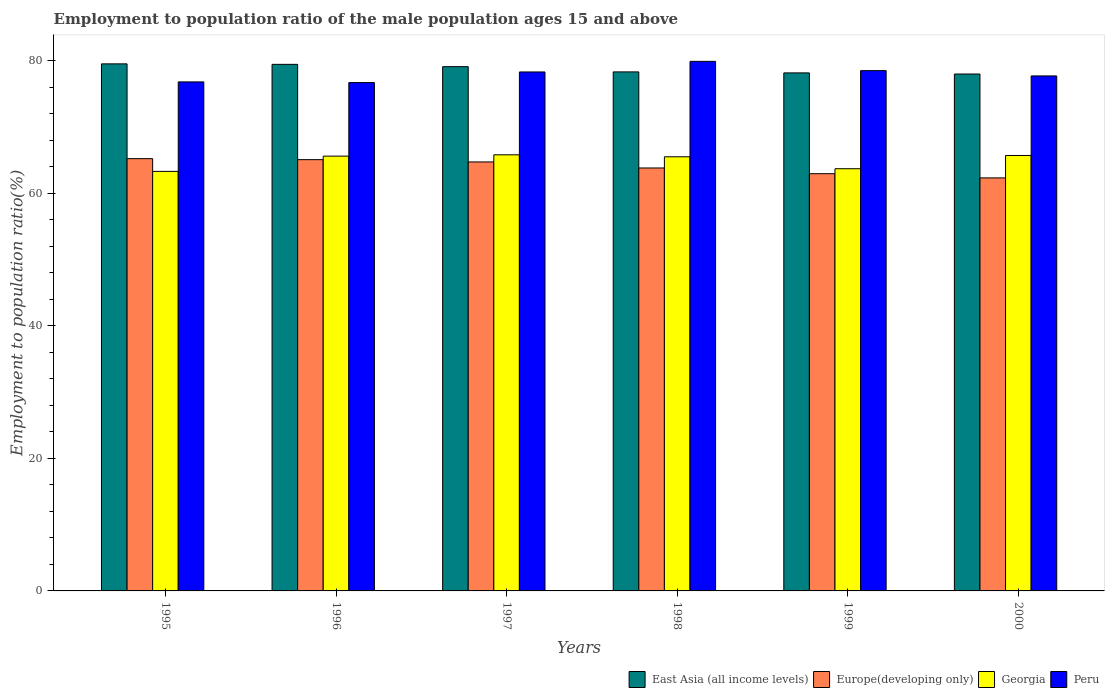How many groups of bars are there?
Ensure brevity in your answer.  6. Are the number of bars on each tick of the X-axis equal?
Keep it short and to the point. Yes. How many bars are there on the 1st tick from the left?
Your response must be concise. 4. How many bars are there on the 2nd tick from the right?
Provide a short and direct response. 4. What is the employment to population ratio in Europe(developing only) in 2000?
Offer a terse response. 62.32. Across all years, what is the maximum employment to population ratio in Peru?
Provide a succinct answer. 79.9. Across all years, what is the minimum employment to population ratio in East Asia (all income levels)?
Offer a very short reply. 77.99. In which year was the employment to population ratio in Peru maximum?
Make the answer very short. 1998. In which year was the employment to population ratio in Peru minimum?
Provide a succinct answer. 1996. What is the total employment to population ratio in Europe(developing only) in the graph?
Your answer should be very brief. 384.09. What is the difference between the employment to population ratio in Peru in 1997 and that in 1998?
Your answer should be very brief. -1.6. What is the difference between the employment to population ratio in East Asia (all income levels) in 2000 and the employment to population ratio in Europe(developing only) in 1995?
Keep it short and to the point. 12.77. What is the average employment to population ratio in Europe(developing only) per year?
Ensure brevity in your answer.  64.02. In the year 1998, what is the difference between the employment to population ratio in Peru and employment to population ratio in Georgia?
Offer a very short reply. 14.4. In how many years, is the employment to population ratio in Peru greater than 28 %?
Provide a succinct answer. 6. What is the ratio of the employment to population ratio in Georgia in 1998 to that in 2000?
Offer a terse response. 1. Is the employment to population ratio in Peru in 1996 less than that in 1998?
Your answer should be very brief. Yes. Is the difference between the employment to population ratio in Peru in 1995 and 1996 greater than the difference between the employment to population ratio in Georgia in 1995 and 1996?
Keep it short and to the point. Yes. What is the difference between the highest and the second highest employment to population ratio in Georgia?
Offer a terse response. 0.1. What is the difference between the highest and the lowest employment to population ratio in Peru?
Your response must be concise. 3.2. In how many years, is the employment to population ratio in Georgia greater than the average employment to population ratio in Georgia taken over all years?
Ensure brevity in your answer.  4. Is it the case that in every year, the sum of the employment to population ratio in Peru and employment to population ratio in Georgia is greater than the sum of employment to population ratio in Europe(developing only) and employment to population ratio in East Asia (all income levels)?
Your response must be concise. Yes. What does the 1st bar from the left in 1997 represents?
Ensure brevity in your answer.  East Asia (all income levels). What does the 4th bar from the right in 2000 represents?
Offer a terse response. East Asia (all income levels). Is it the case that in every year, the sum of the employment to population ratio in Georgia and employment to population ratio in East Asia (all income levels) is greater than the employment to population ratio in Peru?
Your answer should be compact. Yes. How many bars are there?
Your answer should be very brief. 24. Are all the bars in the graph horizontal?
Provide a short and direct response. No. What is the difference between two consecutive major ticks on the Y-axis?
Your response must be concise. 20. Does the graph contain any zero values?
Offer a terse response. No. Does the graph contain grids?
Your answer should be very brief. No. How many legend labels are there?
Ensure brevity in your answer.  4. How are the legend labels stacked?
Keep it short and to the point. Horizontal. What is the title of the graph?
Offer a terse response. Employment to population ratio of the male population ages 15 and above. Does "Luxembourg" appear as one of the legend labels in the graph?
Give a very brief answer. No. What is the label or title of the X-axis?
Give a very brief answer. Years. What is the Employment to population ratio(%) in East Asia (all income levels) in 1995?
Offer a very short reply. 79.52. What is the Employment to population ratio(%) in Europe(developing only) in 1995?
Provide a short and direct response. 65.22. What is the Employment to population ratio(%) of Georgia in 1995?
Make the answer very short. 63.3. What is the Employment to population ratio(%) in Peru in 1995?
Keep it short and to the point. 76.8. What is the Employment to population ratio(%) in East Asia (all income levels) in 1996?
Keep it short and to the point. 79.45. What is the Employment to population ratio(%) in Europe(developing only) in 1996?
Your answer should be compact. 65.07. What is the Employment to population ratio(%) of Georgia in 1996?
Offer a very short reply. 65.6. What is the Employment to population ratio(%) of Peru in 1996?
Offer a terse response. 76.7. What is the Employment to population ratio(%) of East Asia (all income levels) in 1997?
Offer a terse response. 79.1. What is the Employment to population ratio(%) in Europe(developing only) in 1997?
Give a very brief answer. 64.72. What is the Employment to population ratio(%) in Georgia in 1997?
Keep it short and to the point. 65.8. What is the Employment to population ratio(%) of Peru in 1997?
Provide a short and direct response. 78.3. What is the Employment to population ratio(%) of East Asia (all income levels) in 1998?
Give a very brief answer. 78.31. What is the Employment to population ratio(%) in Europe(developing only) in 1998?
Your answer should be compact. 63.81. What is the Employment to population ratio(%) in Georgia in 1998?
Offer a very short reply. 65.5. What is the Employment to population ratio(%) in Peru in 1998?
Make the answer very short. 79.9. What is the Employment to population ratio(%) in East Asia (all income levels) in 1999?
Make the answer very short. 78.16. What is the Employment to population ratio(%) of Europe(developing only) in 1999?
Ensure brevity in your answer.  62.95. What is the Employment to population ratio(%) in Georgia in 1999?
Make the answer very short. 63.7. What is the Employment to population ratio(%) in Peru in 1999?
Provide a short and direct response. 78.5. What is the Employment to population ratio(%) in East Asia (all income levels) in 2000?
Your response must be concise. 77.99. What is the Employment to population ratio(%) in Europe(developing only) in 2000?
Give a very brief answer. 62.32. What is the Employment to population ratio(%) in Georgia in 2000?
Offer a very short reply. 65.7. What is the Employment to population ratio(%) in Peru in 2000?
Offer a very short reply. 77.7. Across all years, what is the maximum Employment to population ratio(%) in East Asia (all income levels)?
Your answer should be compact. 79.52. Across all years, what is the maximum Employment to population ratio(%) of Europe(developing only)?
Offer a terse response. 65.22. Across all years, what is the maximum Employment to population ratio(%) in Georgia?
Make the answer very short. 65.8. Across all years, what is the maximum Employment to population ratio(%) of Peru?
Your response must be concise. 79.9. Across all years, what is the minimum Employment to population ratio(%) of East Asia (all income levels)?
Give a very brief answer. 77.99. Across all years, what is the minimum Employment to population ratio(%) of Europe(developing only)?
Offer a very short reply. 62.32. Across all years, what is the minimum Employment to population ratio(%) in Georgia?
Offer a very short reply. 63.3. Across all years, what is the minimum Employment to population ratio(%) of Peru?
Offer a terse response. 76.7. What is the total Employment to population ratio(%) in East Asia (all income levels) in the graph?
Provide a short and direct response. 472.53. What is the total Employment to population ratio(%) of Europe(developing only) in the graph?
Your answer should be compact. 384.09. What is the total Employment to population ratio(%) in Georgia in the graph?
Make the answer very short. 389.6. What is the total Employment to population ratio(%) of Peru in the graph?
Offer a very short reply. 467.9. What is the difference between the Employment to population ratio(%) in East Asia (all income levels) in 1995 and that in 1996?
Provide a short and direct response. 0.07. What is the difference between the Employment to population ratio(%) in Europe(developing only) in 1995 and that in 1996?
Your answer should be compact. 0.15. What is the difference between the Employment to population ratio(%) of Peru in 1995 and that in 1996?
Give a very brief answer. 0.1. What is the difference between the Employment to population ratio(%) of East Asia (all income levels) in 1995 and that in 1997?
Ensure brevity in your answer.  0.42. What is the difference between the Employment to population ratio(%) in Europe(developing only) in 1995 and that in 1997?
Your answer should be very brief. 0.5. What is the difference between the Employment to population ratio(%) in Georgia in 1995 and that in 1997?
Your answer should be very brief. -2.5. What is the difference between the Employment to population ratio(%) of East Asia (all income levels) in 1995 and that in 1998?
Your answer should be compact. 1.21. What is the difference between the Employment to population ratio(%) in Europe(developing only) in 1995 and that in 1998?
Your response must be concise. 1.41. What is the difference between the Employment to population ratio(%) of Georgia in 1995 and that in 1998?
Your answer should be compact. -2.2. What is the difference between the Employment to population ratio(%) of Peru in 1995 and that in 1998?
Your response must be concise. -3.1. What is the difference between the Employment to population ratio(%) in East Asia (all income levels) in 1995 and that in 1999?
Provide a short and direct response. 1.36. What is the difference between the Employment to population ratio(%) in Europe(developing only) in 1995 and that in 1999?
Give a very brief answer. 2.27. What is the difference between the Employment to population ratio(%) of Georgia in 1995 and that in 1999?
Make the answer very short. -0.4. What is the difference between the Employment to population ratio(%) of Peru in 1995 and that in 1999?
Your answer should be very brief. -1.7. What is the difference between the Employment to population ratio(%) in East Asia (all income levels) in 1995 and that in 2000?
Your answer should be very brief. 1.53. What is the difference between the Employment to population ratio(%) of Europe(developing only) in 1995 and that in 2000?
Provide a succinct answer. 2.9. What is the difference between the Employment to population ratio(%) in Peru in 1995 and that in 2000?
Keep it short and to the point. -0.9. What is the difference between the Employment to population ratio(%) of East Asia (all income levels) in 1996 and that in 1997?
Keep it short and to the point. 0.35. What is the difference between the Employment to population ratio(%) of Europe(developing only) in 1996 and that in 1997?
Your response must be concise. 0.35. What is the difference between the Employment to population ratio(%) in Peru in 1996 and that in 1997?
Provide a succinct answer. -1.6. What is the difference between the Employment to population ratio(%) of East Asia (all income levels) in 1996 and that in 1998?
Make the answer very short. 1.14. What is the difference between the Employment to population ratio(%) in Europe(developing only) in 1996 and that in 1998?
Your answer should be very brief. 1.26. What is the difference between the Employment to population ratio(%) of Peru in 1996 and that in 1998?
Provide a succinct answer. -3.2. What is the difference between the Employment to population ratio(%) in East Asia (all income levels) in 1996 and that in 1999?
Offer a very short reply. 1.29. What is the difference between the Employment to population ratio(%) in Europe(developing only) in 1996 and that in 1999?
Provide a succinct answer. 2.12. What is the difference between the Employment to population ratio(%) in Georgia in 1996 and that in 1999?
Your answer should be very brief. 1.9. What is the difference between the Employment to population ratio(%) in East Asia (all income levels) in 1996 and that in 2000?
Make the answer very short. 1.46. What is the difference between the Employment to population ratio(%) of Europe(developing only) in 1996 and that in 2000?
Offer a terse response. 2.75. What is the difference between the Employment to population ratio(%) in Georgia in 1996 and that in 2000?
Your answer should be very brief. -0.1. What is the difference between the Employment to population ratio(%) of Peru in 1996 and that in 2000?
Keep it short and to the point. -1. What is the difference between the Employment to population ratio(%) in East Asia (all income levels) in 1997 and that in 1998?
Provide a short and direct response. 0.79. What is the difference between the Employment to population ratio(%) of Europe(developing only) in 1997 and that in 1998?
Your response must be concise. 0.91. What is the difference between the Employment to population ratio(%) in Georgia in 1997 and that in 1998?
Offer a terse response. 0.3. What is the difference between the Employment to population ratio(%) in East Asia (all income levels) in 1997 and that in 1999?
Your response must be concise. 0.94. What is the difference between the Employment to population ratio(%) of Europe(developing only) in 1997 and that in 1999?
Offer a very short reply. 1.77. What is the difference between the Employment to population ratio(%) of Georgia in 1997 and that in 1999?
Give a very brief answer. 2.1. What is the difference between the Employment to population ratio(%) of East Asia (all income levels) in 1997 and that in 2000?
Make the answer very short. 1.11. What is the difference between the Employment to population ratio(%) of Europe(developing only) in 1997 and that in 2000?
Your answer should be compact. 2.41. What is the difference between the Employment to population ratio(%) of East Asia (all income levels) in 1998 and that in 1999?
Your answer should be compact. 0.15. What is the difference between the Employment to population ratio(%) in Europe(developing only) in 1998 and that in 1999?
Keep it short and to the point. 0.86. What is the difference between the Employment to population ratio(%) of Georgia in 1998 and that in 1999?
Provide a succinct answer. 1.8. What is the difference between the Employment to population ratio(%) in East Asia (all income levels) in 1998 and that in 2000?
Ensure brevity in your answer.  0.32. What is the difference between the Employment to population ratio(%) of Europe(developing only) in 1998 and that in 2000?
Offer a very short reply. 1.5. What is the difference between the Employment to population ratio(%) of Georgia in 1998 and that in 2000?
Provide a short and direct response. -0.2. What is the difference between the Employment to population ratio(%) in East Asia (all income levels) in 1999 and that in 2000?
Ensure brevity in your answer.  0.17. What is the difference between the Employment to population ratio(%) of Europe(developing only) in 1999 and that in 2000?
Your answer should be compact. 0.63. What is the difference between the Employment to population ratio(%) in Peru in 1999 and that in 2000?
Provide a short and direct response. 0.8. What is the difference between the Employment to population ratio(%) in East Asia (all income levels) in 1995 and the Employment to population ratio(%) in Europe(developing only) in 1996?
Your answer should be very brief. 14.45. What is the difference between the Employment to population ratio(%) of East Asia (all income levels) in 1995 and the Employment to population ratio(%) of Georgia in 1996?
Offer a terse response. 13.92. What is the difference between the Employment to population ratio(%) in East Asia (all income levels) in 1995 and the Employment to population ratio(%) in Peru in 1996?
Offer a very short reply. 2.82. What is the difference between the Employment to population ratio(%) in Europe(developing only) in 1995 and the Employment to population ratio(%) in Georgia in 1996?
Your answer should be compact. -0.38. What is the difference between the Employment to population ratio(%) in Europe(developing only) in 1995 and the Employment to population ratio(%) in Peru in 1996?
Provide a succinct answer. -11.48. What is the difference between the Employment to population ratio(%) in Georgia in 1995 and the Employment to population ratio(%) in Peru in 1996?
Your response must be concise. -13.4. What is the difference between the Employment to population ratio(%) of East Asia (all income levels) in 1995 and the Employment to population ratio(%) of Europe(developing only) in 1997?
Keep it short and to the point. 14.8. What is the difference between the Employment to population ratio(%) in East Asia (all income levels) in 1995 and the Employment to population ratio(%) in Georgia in 1997?
Offer a terse response. 13.72. What is the difference between the Employment to population ratio(%) of East Asia (all income levels) in 1995 and the Employment to population ratio(%) of Peru in 1997?
Provide a short and direct response. 1.22. What is the difference between the Employment to population ratio(%) in Europe(developing only) in 1995 and the Employment to population ratio(%) in Georgia in 1997?
Make the answer very short. -0.58. What is the difference between the Employment to population ratio(%) in Europe(developing only) in 1995 and the Employment to population ratio(%) in Peru in 1997?
Offer a terse response. -13.08. What is the difference between the Employment to population ratio(%) in Georgia in 1995 and the Employment to population ratio(%) in Peru in 1997?
Make the answer very short. -15. What is the difference between the Employment to population ratio(%) in East Asia (all income levels) in 1995 and the Employment to population ratio(%) in Europe(developing only) in 1998?
Your answer should be compact. 15.71. What is the difference between the Employment to population ratio(%) in East Asia (all income levels) in 1995 and the Employment to population ratio(%) in Georgia in 1998?
Provide a short and direct response. 14.02. What is the difference between the Employment to population ratio(%) of East Asia (all income levels) in 1995 and the Employment to population ratio(%) of Peru in 1998?
Provide a succinct answer. -0.38. What is the difference between the Employment to population ratio(%) in Europe(developing only) in 1995 and the Employment to population ratio(%) in Georgia in 1998?
Offer a terse response. -0.28. What is the difference between the Employment to population ratio(%) in Europe(developing only) in 1995 and the Employment to population ratio(%) in Peru in 1998?
Give a very brief answer. -14.68. What is the difference between the Employment to population ratio(%) in Georgia in 1995 and the Employment to population ratio(%) in Peru in 1998?
Offer a very short reply. -16.6. What is the difference between the Employment to population ratio(%) in East Asia (all income levels) in 1995 and the Employment to population ratio(%) in Europe(developing only) in 1999?
Keep it short and to the point. 16.57. What is the difference between the Employment to population ratio(%) of East Asia (all income levels) in 1995 and the Employment to population ratio(%) of Georgia in 1999?
Your answer should be compact. 15.82. What is the difference between the Employment to population ratio(%) in East Asia (all income levels) in 1995 and the Employment to population ratio(%) in Peru in 1999?
Offer a very short reply. 1.02. What is the difference between the Employment to population ratio(%) of Europe(developing only) in 1995 and the Employment to population ratio(%) of Georgia in 1999?
Ensure brevity in your answer.  1.52. What is the difference between the Employment to population ratio(%) in Europe(developing only) in 1995 and the Employment to population ratio(%) in Peru in 1999?
Your response must be concise. -13.28. What is the difference between the Employment to population ratio(%) in Georgia in 1995 and the Employment to population ratio(%) in Peru in 1999?
Your response must be concise. -15.2. What is the difference between the Employment to population ratio(%) in East Asia (all income levels) in 1995 and the Employment to population ratio(%) in Europe(developing only) in 2000?
Keep it short and to the point. 17.2. What is the difference between the Employment to population ratio(%) in East Asia (all income levels) in 1995 and the Employment to population ratio(%) in Georgia in 2000?
Your answer should be compact. 13.82. What is the difference between the Employment to population ratio(%) of East Asia (all income levels) in 1995 and the Employment to population ratio(%) of Peru in 2000?
Provide a short and direct response. 1.82. What is the difference between the Employment to population ratio(%) of Europe(developing only) in 1995 and the Employment to population ratio(%) of Georgia in 2000?
Keep it short and to the point. -0.48. What is the difference between the Employment to population ratio(%) in Europe(developing only) in 1995 and the Employment to population ratio(%) in Peru in 2000?
Your answer should be very brief. -12.48. What is the difference between the Employment to population ratio(%) of Georgia in 1995 and the Employment to population ratio(%) of Peru in 2000?
Offer a very short reply. -14.4. What is the difference between the Employment to population ratio(%) of East Asia (all income levels) in 1996 and the Employment to population ratio(%) of Europe(developing only) in 1997?
Give a very brief answer. 14.73. What is the difference between the Employment to population ratio(%) of East Asia (all income levels) in 1996 and the Employment to population ratio(%) of Georgia in 1997?
Provide a short and direct response. 13.65. What is the difference between the Employment to population ratio(%) of East Asia (all income levels) in 1996 and the Employment to population ratio(%) of Peru in 1997?
Make the answer very short. 1.15. What is the difference between the Employment to population ratio(%) of Europe(developing only) in 1996 and the Employment to population ratio(%) of Georgia in 1997?
Ensure brevity in your answer.  -0.73. What is the difference between the Employment to population ratio(%) in Europe(developing only) in 1996 and the Employment to population ratio(%) in Peru in 1997?
Give a very brief answer. -13.23. What is the difference between the Employment to population ratio(%) of Georgia in 1996 and the Employment to population ratio(%) of Peru in 1997?
Ensure brevity in your answer.  -12.7. What is the difference between the Employment to population ratio(%) in East Asia (all income levels) in 1996 and the Employment to population ratio(%) in Europe(developing only) in 1998?
Offer a terse response. 15.63. What is the difference between the Employment to population ratio(%) of East Asia (all income levels) in 1996 and the Employment to population ratio(%) of Georgia in 1998?
Your response must be concise. 13.95. What is the difference between the Employment to population ratio(%) in East Asia (all income levels) in 1996 and the Employment to population ratio(%) in Peru in 1998?
Offer a very short reply. -0.45. What is the difference between the Employment to population ratio(%) of Europe(developing only) in 1996 and the Employment to population ratio(%) of Georgia in 1998?
Your answer should be very brief. -0.43. What is the difference between the Employment to population ratio(%) in Europe(developing only) in 1996 and the Employment to population ratio(%) in Peru in 1998?
Ensure brevity in your answer.  -14.83. What is the difference between the Employment to population ratio(%) of Georgia in 1996 and the Employment to population ratio(%) of Peru in 1998?
Ensure brevity in your answer.  -14.3. What is the difference between the Employment to population ratio(%) of East Asia (all income levels) in 1996 and the Employment to population ratio(%) of Europe(developing only) in 1999?
Provide a succinct answer. 16.5. What is the difference between the Employment to population ratio(%) in East Asia (all income levels) in 1996 and the Employment to population ratio(%) in Georgia in 1999?
Ensure brevity in your answer.  15.75. What is the difference between the Employment to population ratio(%) of East Asia (all income levels) in 1996 and the Employment to population ratio(%) of Peru in 1999?
Ensure brevity in your answer.  0.95. What is the difference between the Employment to population ratio(%) of Europe(developing only) in 1996 and the Employment to population ratio(%) of Georgia in 1999?
Your answer should be very brief. 1.37. What is the difference between the Employment to population ratio(%) in Europe(developing only) in 1996 and the Employment to population ratio(%) in Peru in 1999?
Provide a short and direct response. -13.43. What is the difference between the Employment to population ratio(%) of East Asia (all income levels) in 1996 and the Employment to population ratio(%) of Europe(developing only) in 2000?
Make the answer very short. 17.13. What is the difference between the Employment to population ratio(%) of East Asia (all income levels) in 1996 and the Employment to population ratio(%) of Georgia in 2000?
Offer a terse response. 13.75. What is the difference between the Employment to population ratio(%) of East Asia (all income levels) in 1996 and the Employment to population ratio(%) of Peru in 2000?
Your answer should be compact. 1.75. What is the difference between the Employment to population ratio(%) of Europe(developing only) in 1996 and the Employment to population ratio(%) of Georgia in 2000?
Keep it short and to the point. -0.63. What is the difference between the Employment to population ratio(%) in Europe(developing only) in 1996 and the Employment to population ratio(%) in Peru in 2000?
Your answer should be compact. -12.63. What is the difference between the Employment to population ratio(%) of Georgia in 1996 and the Employment to population ratio(%) of Peru in 2000?
Give a very brief answer. -12.1. What is the difference between the Employment to population ratio(%) in East Asia (all income levels) in 1997 and the Employment to population ratio(%) in Europe(developing only) in 1998?
Provide a short and direct response. 15.29. What is the difference between the Employment to population ratio(%) of East Asia (all income levels) in 1997 and the Employment to population ratio(%) of Georgia in 1998?
Provide a short and direct response. 13.6. What is the difference between the Employment to population ratio(%) of East Asia (all income levels) in 1997 and the Employment to population ratio(%) of Peru in 1998?
Keep it short and to the point. -0.8. What is the difference between the Employment to population ratio(%) of Europe(developing only) in 1997 and the Employment to population ratio(%) of Georgia in 1998?
Make the answer very short. -0.78. What is the difference between the Employment to population ratio(%) in Europe(developing only) in 1997 and the Employment to population ratio(%) in Peru in 1998?
Keep it short and to the point. -15.18. What is the difference between the Employment to population ratio(%) in Georgia in 1997 and the Employment to population ratio(%) in Peru in 1998?
Keep it short and to the point. -14.1. What is the difference between the Employment to population ratio(%) in East Asia (all income levels) in 1997 and the Employment to population ratio(%) in Europe(developing only) in 1999?
Make the answer very short. 16.15. What is the difference between the Employment to population ratio(%) of East Asia (all income levels) in 1997 and the Employment to population ratio(%) of Georgia in 1999?
Your answer should be very brief. 15.4. What is the difference between the Employment to population ratio(%) in East Asia (all income levels) in 1997 and the Employment to population ratio(%) in Peru in 1999?
Your response must be concise. 0.6. What is the difference between the Employment to population ratio(%) in Europe(developing only) in 1997 and the Employment to population ratio(%) in Georgia in 1999?
Provide a short and direct response. 1.02. What is the difference between the Employment to population ratio(%) of Europe(developing only) in 1997 and the Employment to population ratio(%) of Peru in 1999?
Give a very brief answer. -13.78. What is the difference between the Employment to population ratio(%) in Georgia in 1997 and the Employment to population ratio(%) in Peru in 1999?
Ensure brevity in your answer.  -12.7. What is the difference between the Employment to population ratio(%) in East Asia (all income levels) in 1997 and the Employment to population ratio(%) in Europe(developing only) in 2000?
Your answer should be very brief. 16.78. What is the difference between the Employment to population ratio(%) of East Asia (all income levels) in 1997 and the Employment to population ratio(%) of Peru in 2000?
Your response must be concise. 1.4. What is the difference between the Employment to population ratio(%) in Europe(developing only) in 1997 and the Employment to population ratio(%) in Georgia in 2000?
Ensure brevity in your answer.  -0.98. What is the difference between the Employment to population ratio(%) in Europe(developing only) in 1997 and the Employment to population ratio(%) in Peru in 2000?
Make the answer very short. -12.98. What is the difference between the Employment to population ratio(%) in East Asia (all income levels) in 1998 and the Employment to population ratio(%) in Europe(developing only) in 1999?
Offer a terse response. 15.36. What is the difference between the Employment to population ratio(%) of East Asia (all income levels) in 1998 and the Employment to population ratio(%) of Georgia in 1999?
Your response must be concise. 14.61. What is the difference between the Employment to population ratio(%) in East Asia (all income levels) in 1998 and the Employment to population ratio(%) in Peru in 1999?
Ensure brevity in your answer.  -0.19. What is the difference between the Employment to population ratio(%) in Europe(developing only) in 1998 and the Employment to population ratio(%) in Georgia in 1999?
Offer a very short reply. 0.11. What is the difference between the Employment to population ratio(%) of Europe(developing only) in 1998 and the Employment to population ratio(%) of Peru in 1999?
Keep it short and to the point. -14.69. What is the difference between the Employment to population ratio(%) in East Asia (all income levels) in 1998 and the Employment to population ratio(%) in Europe(developing only) in 2000?
Ensure brevity in your answer.  15.99. What is the difference between the Employment to population ratio(%) of East Asia (all income levels) in 1998 and the Employment to population ratio(%) of Georgia in 2000?
Your answer should be compact. 12.61. What is the difference between the Employment to population ratio(%) in East Asia (all income levels) in 1998 and the Employment to population ratio(%) in Peru in 2000?
Your answer should be very brief. 0.61. What is the difference between the Employment to population ratio(%) of Europe(developing only) in 1998 and the Employment to population ratio(%) of Georgia in 2000?
Your answer should be very brief. -1.89. What is the difference between the Employment to population ratio(%) of Europe(developing only) in 1998 and the Employment to population ratio(%) of Peru in 2000?
Give a very brief answer. -13.89. What is the difference between the Employment to population ratio(%) of East Asia (all income levels) in 1999 and the Employment to population ratio(%) of Europe(developing only) in 2000?
Make the answer very short. 15.84. What is the difference between the Employment to population ratio(%) in East Asia (all income levels) in 1999 and the Employment to population ratio(%) in Georgia in 2000?
Your answer should be very brief. 12.46. What is the difference between the Employment to population ratio(%) in East Asia (all income levels) in 1999 and the Employment to population ratio(%) in Peru in 2000?
Offer a terse response. 0.46. What is the difference between the Employment to population ratio(%) in Europe(developing only) in 1999 and the Employment to population ratio(%) in Georgia in 2000?
Provide a succinct answer. -2.75. What is the difference between the Employment to population ratio(%) of Europe(developing only) in 1999 and the Employment to population ratio(%) of Peru in 2000?
Provide a short and direct response. -14.75. What is the average Employment to population ratio(%) in East Asia (all income levels) per year?
Provide a succinct answer. 78.75. What is the average Employment to population ratio(%) of Europe(developing only) per year?
Your answer should be compact. 64.02. What is the average Employment to population ratio(%) in Georgia per year?
Provide a short and direct response. 64.93. What is the average Employment to population ratio(%) in Peru per year?
Keep it short and to the point. 77.98. In the year 1995, what is the difference between the Employment to population ratio(%) in East Asia (all income levels) and Employment to population ratio(%) in Europe(developing only)?
Provide a short and direct response. 14.3. In the year 1995, what is the difference between the Employment to population ratio(%) in East Asia (all income levels) and Employment to population ratio(%) in Georgia?
Provide a succinct answer. 16.22. In the year 1995, what is the difference between the Employment to population ratio(%) in East Asia (all income levels) and Employment to population ratio(%) in Peru?
Give a very brief answer. 2.72. In the year 1995, what is the difference between the Employment to population ratio(%) of Europe(developing only) and Employment to population ratio(%) of Georgia?
Provide a short and direct response. 1.92. In the year 1995, what is the difference between the Employment to population ratio(%) of Europe(developing only) and Employment to population ratio(%) of Peru?
Provide a succinct answer. -11.58. In the year 1996, what is the difference between the Employment to population ratio(%) in East Asia (all income levels) and Employment to population ratio(%) in Europe(developing only)?
Provide a succinct answer. 14.38. In the year 1996, what is the difference between the Employment to population ratio(%) in East Asia (all income levels) and Employment to population ratio(%) in Georgia?
Your answer should be compact. 13.85. In the year 1996, what is the difference between the Employment to population ratio(%) of East Asia (all income levels) and Employment to population ratio(%) of Peru?
Give a very brief answer. 2.75. In the year 1996, what is the difference between the Employment to population ratio(%) of Europe(developing only) and Employment to population ratio(%) of Georgia?
Provide a succinct answer. -0.53. In the year 1996, what is the difference between the Employment to population ratio(%) of Europe(developing only) and Employment to population ratio(%) of Peru?
Your answer should be very brief. -11.63. In the year 1996, what is the difference between the Employment to population ratio(%) in Georgia and Employment to population ratio(%) in Peru?
Your response must be concise. -11.1. In the year 1997, what is the difference between the Employment to population ratio(%) in East Asia (all income levels) and Employment to population ratio(%) in Europe(developing only)?
Your answer should be very brief. 14.38. In the year 1997, what is the difference between the Employment to population ratio(%) of East Asia (all income levels) and Employment to population ratio(%) of Georgia?
Keep it short and to the point. 13.3. In the year 1997, what is the difference between the Employment to population ratio(%) in East Asia (all income levels) and Employment to population ratio(%) in Peru?
Make the answer very short. 0.8. In the year 1997, what is the difference between the Employment to population ratio(%) in Europe(developing only) and Employment to population ratio(%) in Georgia?
Give a very brief answer. -1.08. In the year 1997, what is the difference between the Employment to population ratio(%) in Europe(developing only) and Employment to population ratio(%) in Peru?
Provide a succinct answer. -13.58. In the year 1998, what is the difference between the Employment to population ratio(%) of East Asia (all income levels) and Employment to population ratio(%) of Europe(developing only)?
Your answer should be compact. 14.5. In the year 1998, what is the difference between the Employment to population ratio(%) in East Asia (all income levels) and Employment to population ratio(%) in Georgia?
Offer a terse response. 12.81. In the year 1998, what is the difference between the Employment to population ratio(%) in East Asia (all income levels) and Employment to population ratio(%) in Peru?
Make the answer very short. -1.59. In the year 1998, what is the difference between the Employment to population ratio(%) in Europe(developing only) and Employment to population ratio(%) in Georgia?
Your response must be concise. -1.69. In the year 1998, what is the difference between the Employment to population ratio(%) of Europe(developing only) and Employment to population ratio(%) of Peru?
Provide a succinct answer. -16.09. In the year 1998, what is the difference between the Employment to population ratio(%) of Georgia and Employment to population ratio(%) of Peru?
Your answer should be compact. -14.4. In the year 1999, what is the difference between the Employment to population ratio(%) of East Asia (all income levels) and Employment to population ratio(%) of Europe(developing only)?
Offer a terse response. 15.21. In the year 1999, what is the difference between the Employment to population ratio(%) of East Asia (all income levels) and Employment to population ratio(%) of Georgia?
Ensure brevity in your answer.  14.46. In the year 1999, what is the difference between the Employment to population ratio(%) of East Asia (all income levels) and Employment to population ratio(%) of Peru?
Give a very brief answer. -0.34. In the year 1999, what is the difference between the Employment to population ratio(%) in Europe(developing only) and Employment to population ratio(%) in Georgia?
Keep it short and to the point. -0.75. In the year 1999, what is the difference between the Employment to population ratio(%) in Europe(developing only) and Employment to population ratio(%) in Peru?
Give a very brief answer. -15.55. In the year 1999, what is the difference between the Employment to population ratio(%) in Georgia and Employment to population ratio(%) in Peru?
Make the answer very short. -14.8. In the year 2000, what is the difference between the Employment to population ratio(%) in East Asia (all income levels) and Employment to population ratio(%) in Europe(developing only)?
Offer a terse response. 15.67. In the year 2000, what is the difference between the Employment to population ratio(%) of East Asia (all income levels) and Employment to population ratio(%) of Georgia?
Make the answer very short. 12.29. In the year 2000, what is the difference between the Employment to population ratio(%) in East Asia (all income levels) and Employment to population ratio(%) in Peru?
Offer a terse response. 0.29. In the year 2000, what is the difference between the Employment to population ratio(%) of Europe(developing only) and Employment to population ratio(%) of Georgia?
Ensure brevity in your answer.  -3.38. In the year 2000, what is the difference between the Employment to population ratio(%) of Europe(developing only) and Employment to population ratio(%) of Peru?
Keep it short and to the point. -15.38. What is the ratio of the Employment to population ratio(%) of East Asia (all income levels) in 1995 to that in 1996?
Your answer should be compact. 1. What is the ratio of the Employment to population ratio(%) of Europe(developing only) in 1995 to that in 1996?
Provide a succinct answer. 1. What is the ratio of the Employment to population ratio(%) of Georgia in 1995 to that in 1996?
Make the answer very short. 0.96. What is the ratio of the Employment to population ratio(%) of Peru in 1995 to that in 1996?
Provide a short and direct response. 1. What is the ratio of the Employment to population ratio(%) of East Asia (all income levels) in 1995 to that in 1997?
Offer a very short reply. 1.01. What is the ratio of the Employment to population ratio(%) of Europe(developing only) in 1995 to that in 1997?
Give a very brief answer. 1.01. What is the ratio of the Employment to population ratio(%) in Peru in 1995 to that in 1997?
Offer a terse response. 0.98. What is the ratio of the Employment to population ratio(%) in East Asia (all income levels) in 1995 to that in 1998?
Provide a short and direct response. 1.02. What is the ratio of the Employment to population ratio(%) of Georgia in 1995 to that in 1998?
Your answer should be compact. 0.97. What is the ratio of the Employment to population ratio(%) in Peru in 1995 to that in 1998?
Your answer should be compact. 0.96. What is the ratio of the Employment to population ratio(%) of East Asia (all income levels) in 1995 to that in 1999?
Offer a terse response. 1.02. What is the ratio of the Employment to population ratio(%) of Europe(developing only) in 1995 to that in 1999?
Provide a succinct answer. 1.04. What is the ratio of the Employment to population ratio(%) of Georgia in 1995 to that in 1999?
Make the answer very short. 0.99. What is the ratio of the Employment to population ratio(%) in Peru in 1995 to that in 1999?
Keep it short and to the point. 0.98. What is the ratio of the Employment to population ratio(%) of East Asia (all income levels) in 1995 to that in 2000?
Your answer should be compact. 1.02. What is the ratio of the Employment to population ratio(%) of Europe(developing only) in 1995 to that in 2000?
Give a very brief answer. 1.05. What is the ratio of the Employment to population ratio(%) of Georgia in 1995 to that in 2000?
Give a very brief answer. 0.96. What is the ratio of the Employment to population ratio(%) in Peru in 1995 to that in 2000?
Make the answer very short. 0.99. What is the ratio of the Employment to population ratio(%) of East Asia (all income levels) in 1996 to that in 1997?
Your response must be concise. 1. What is the ratio of the Employment to population ratio(%) in Europe(developing only) in 1996 to that in 1997?
Provide a succinct answer. 1.01. What is the ratio of the Employment to population ratio(%) in Peru in 1996 to that in 1997?
Ensure brevity in your answer.  0.98. What is the ratio of the Employment to population ratio(%) in East Asia (all income levels) in 1996 to that in 1998?
Give a very brief answer. 1.01. What is the ratio of the Employment to population ratio(%) in Europe(developing only) in 1996 to that in 1998?
Your answer should be very brief. 1.02. What is the ratio of the Employment to population ratio(%) of Georgia in 1996 to that in 1998?
Your response must be concise. 1. What is the ratio of the Employment to population ratio(%) in Peru in 1996 to that in 1998?
Provide a succinct answer. 0.96. What is the ratio of the Employment to population ratio(%) of East Asia (all income levels) in 1996 to that in 1999?
Offer a terse response. 1.02. What is the ratio of the Employment to population ratio(%) of Europe(developing only) in 1996 to that in 1999?
Provide a succinct answer. 1.03. What is the ratio of the Employment to population ratio(%) of Georgia in 1996 to that in 1999?
Your answer should be very brief. 1.03. What is the ratio of the Employment to population ratio(%) in Peru in 1996 to that in 1999?
Offer a very short reply. 0.98. What is the ratio of the Employment to population ratio(%) in East Asia (all income levels) in 1996 to that in 2000?
Give a very brief answer. 1.02. What is the ratio of the Employment to population ratio(%) of Europe(developing only) in 1996 to that in 2000?
Give a very brief answer. 1.04. What is the ratio of the Employment to population ratio(%) of Georgia in 1996 to that in 2000?
Provide a succinct answer. 1. What is the ratio of the Employment to population ratio(%) of Peru in 1996 to that in 2000?
Give a very brief answer. 0.99. What is the ratio of the Employment to population ratio(%) of East Asia (all income levels) in 1997 to that in 1998?
Offer a very short reply. 1.01. What is the ratio of the Employment to population ratio(%) in Europe(developing only) in 1997 to that in 1998?
Offer a terse response. 1.01. What is the ratio of the Employment to population ratio(%) in East Asia (all income levels) in 1997 to that in 1999?
Offer a terse response. 1.01. What is the ratio of the Employment to population ratio(%) of Europe(developing only) in 1997 to that in 1999?
Your answer should be very brief. 1.03. What is the ratio of the Employment to population ratio(%) of Georgia in 1997 to that in 1999?
Provide a succinct answer. 1.03. What is the ratio of the Employment to population ratio(%) in Peru in 1997 to that in 1999?
Offer a very short reply. 1. What is the ratio of the Employment to population ratio(%) of East Asia (all income levels) in 1997 to that in 2000?
Provide a short and direct response. 1.01. What is the ratio of the Employment to population ratio(%) in Europe(developing only) in 1997 to that in 2000?
Ensure brevity in your answer.  1.04. What is the ratio of the Employment to population ratio(%) in Peru in 1997 to that in 2000?
Ensure brevity in your answer.  1.01. What is the ratio of the Employment to population ratio(%) in East Asia (all income levels) in 1998 to that in 1999?
Make the answer very short. 1. What is the ratio of the Employment to population ratio(%) of Europe(developing only) in 1998 to that in 1999?
Your answer should be very brief. 1.01. What is the ratio of the Employment to population ratio(%) of Georgia in 1998 to that in 1999?
Your response must be concise. 1.03. What is the ratio of the Employment to population ratio(%) in Peru in 1998 to that in 1999?
Provide a short and direct response. 1.02. What is the ratio of the Employment to population ratio(%) in Europe(developing only) in 1998 to that in 2000?
Offer a terse response. 1.02. What is the ratio of the Employment to population ratio(%) in Georgia in 1998 to that in 2000?
Make the answer very short. 1. What is the ratio of the Employment to population ratio(%) of Peru in 1998 to that in 2000?
Offer a terse response. 1.03. What is the ratio of the Employment to population ratio(%) in Europe(developing only) in 1999 to that in 2000?
Your answer should be compact. 1.01. What is the ratio of the Employment to population ratio(%) in Georgia in 1999 to that in 2000?
Your answer should be very brief. 0.97. What is the ratio of the Employment to population ratio(%) in Peru in 1999 to that in 2000?
Offer a terse response. 1.01. What is the difference between the highest and the second highest Employment to population ratio(%) in East Asia (all income levels)?
Your answer should be compact. 0.07. What is the difference between the highest and the second highest Employment to population ratio(%) of Europe(developing only)?
Keep it short and to the point. 0.15. What is the difference between the highest and the lowest Employment to population ratio(%) of East Asia (all income levels)?
Ensure brevity in your answer.  1.53. What is the difference between the highest and the lowest Employment to population ratio(%) of Europe(developing only)?
Your response must be concise. 2.9. 